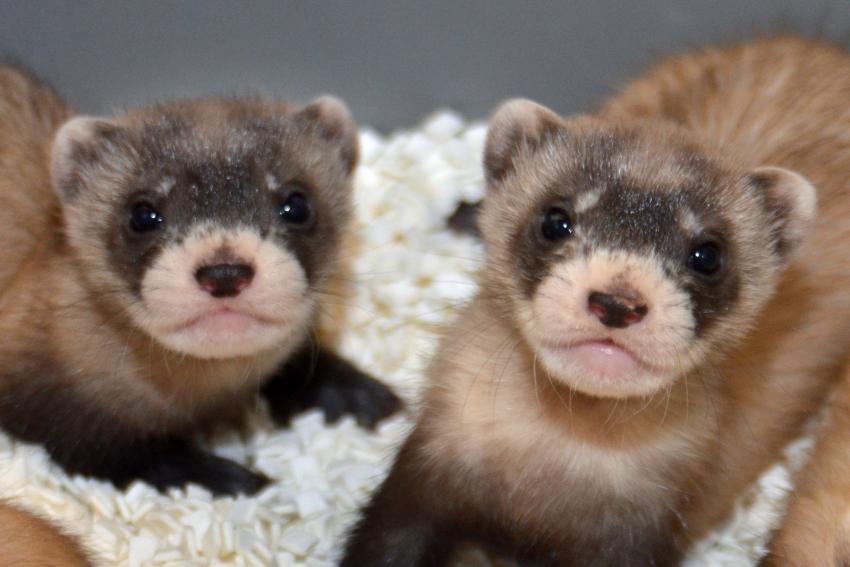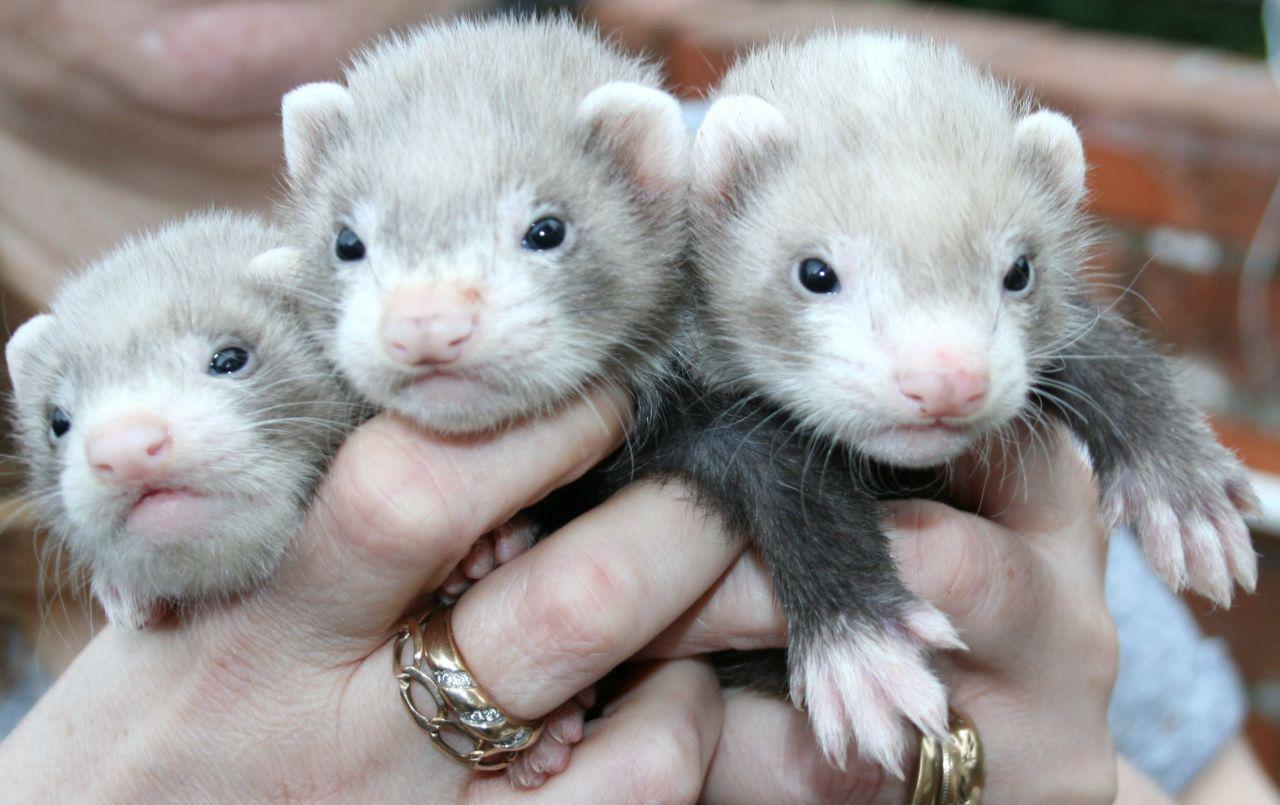The first image is the image on the left, the second image is the image on the right. Given the left and right images, does the statement "There is exactly three ferrets in the right image." hold true? Answer yes or no. Yes. The first image is the image on the left, the second image is the image on the right. For the images displayed, is the sentence "there are 3 ferrets being helpd up together by human hands" factually correct? Answer yes or no. Yes. 